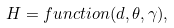<formula> <loc_0><loc_0><loc_500><loc_500>H = f u n c t i o n ( d , \theta , \gamma ) ,</formula> 